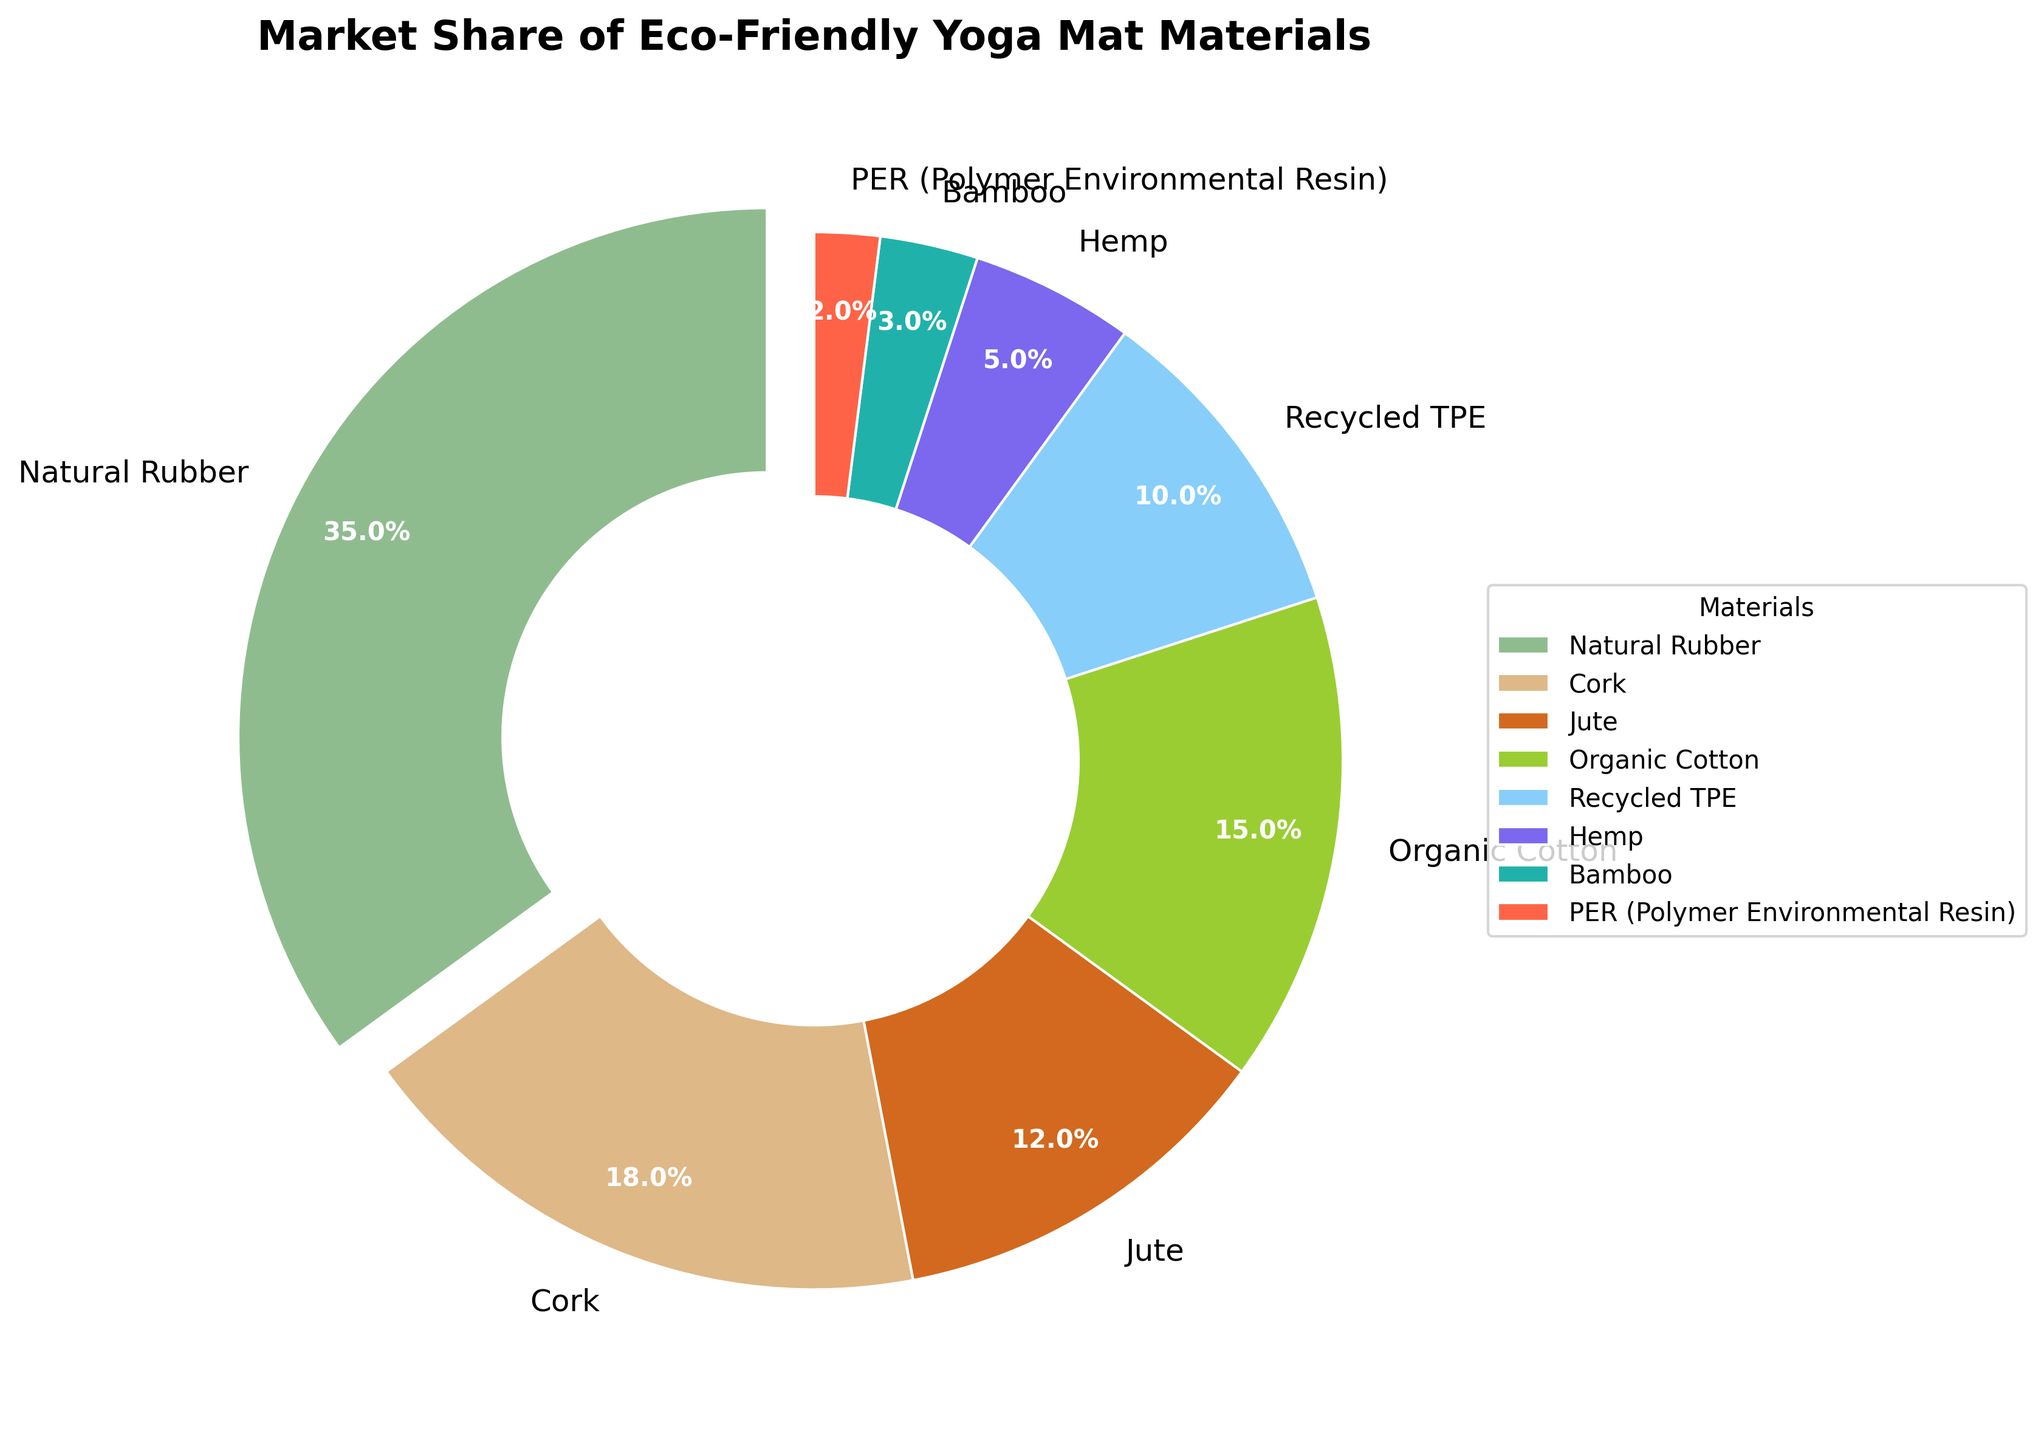Which material has the largest market share? The chart shows that the material with the largest slice is Natural Rubber. By examining the pie chart, we can see that Natural Rubber holds the largest segment with 35% market share.
Answer: Natural Rubber Which material has the smallest market share? The smallest slice in the pie chart is for PER (Polymer Environmental Resin). We can observe that it represents a 2% market share, which is the smallest among all materials.
Answer: PER (Polymer Environmental Resin) What is the combined market share of Cork and Jute? The Cork segment is 18% and the Jute segment is 12%. Adding these two percentages together, 18% + 12% = 30%. This gives us the combined market share for Cork and Jute.
Answer: 30% How does the market share of Organic Cotton compare to Recycled TPE? Organic Cotton has a market share of 15%, whereas Recycled TPE has a market share of 10%. When comparing these two, Organic Cotton has a 5% greater market share than Recycled TPE.
Answer: Organic Cotton has a 5% greater market share than Recycled TPE What is the average market share of Natural Rubber, Hemp, and Bamboo? To find the average, we sum their market shares: Natural Rubber (35%), Hemp (5%), and Bamboo (3%) which equals 35 + 5 + 3 = 43. Then, we divide by the number of materials: 43 / 3 = 14.33 (rounded to two decimal places).
Answer: 14.33% If we were to combine the market shares of Jute and Hemp, would it be larger than that of Organic Cotton? Jute has a market share of 12% and Hemp has 5%. Combining them, 12% + 5% = 17%. Since Organic Cotton is 15%, the combined market share of Jute and Hemp (17%) is indeed larger than that of Organic Cotton (15%).
Answer: Yes Which color segment in the pie chart represents Recycled TPE? Recycled TPE is represented by the light blue segment in the pie chart. It is the fifth segment in the color sequence provided.
Answer: Light blue What is the total market share of all materials other than Natural Rubber? The total market share of all materials other than Natural Rubber is calculated by subtracting Natural Rubber's share from 100%: 100 - 35 = 65%.
Answer: 65% How many materials have a market share greater than 10%? By observing the pie chart, we note that Natural Rubber (35%), Cork (18%), Jute (12%), and Organic Cotton (15%) all have individual market shares greater than 10%. Counting these segments gives us four materials.
Answer: 4 Comparing Bamboo and PER, which one has a higher market share and by how much? Bamboo has a market share of 3% while PER has 2%. Comparing these, Bamboo has a 1% higher market share than PER.
Answer: Bamboo by 1% 